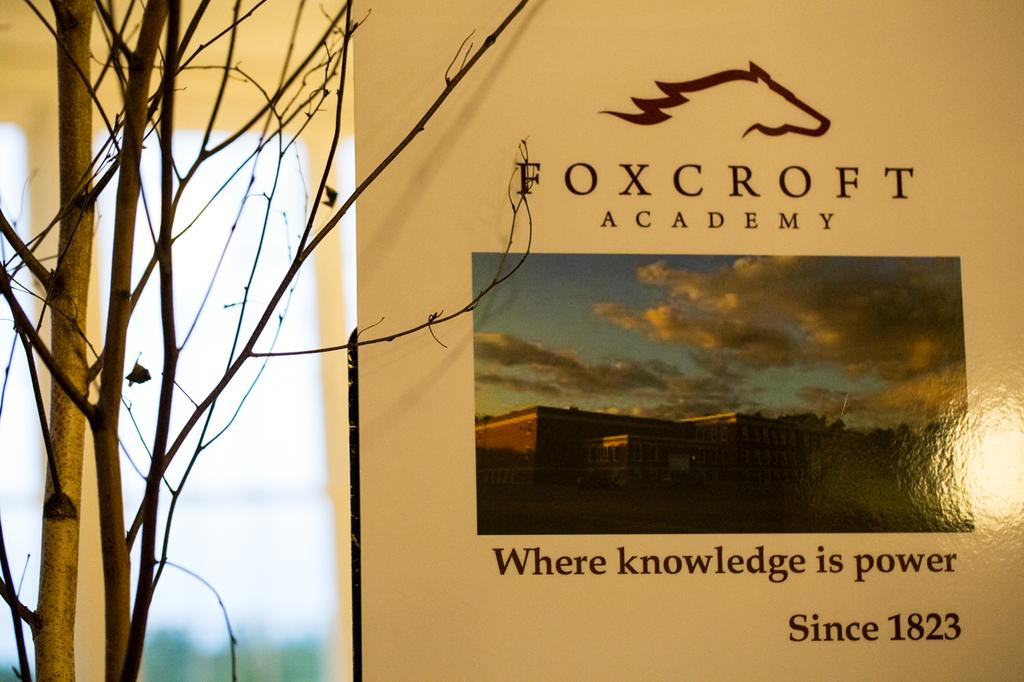What is the main object in the image? There is a hoarding in the image. What can be seen on the hoarding? There is text on the hoarding. What is located near the hoarding? There are plants beside the hoarding. How would you describe the background of the image? The background of the image is blurry. What type of stamp can be seen on the attention-grabbing hoarding? There is no stamp present on the hoarding in the image. How does the hoarding impulsively affect the viewer's emotions? The image does not provide information about the emotional impact on the viewer, nor does it suggest any impulsive reactions. 